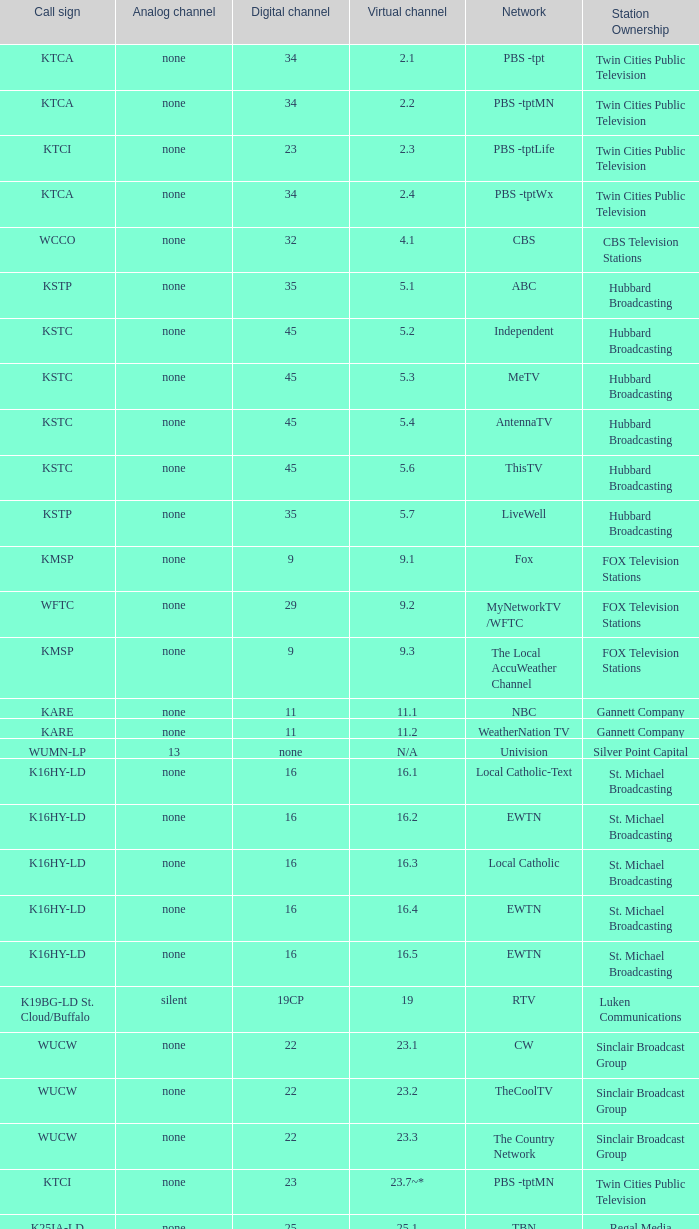Can you parse all the data within this table? {'header': ['Call sign', 'Analog channel', 'Digital channel', 'Virtual channel', 'Network', 'Station Ownership'], 'rows': [['KTCA', 'none', '34', '2.1', 'PBS -tpt', 'Twin Cities Public Television'], ['KTCA', 'none', '34', '2.2', 'PBS -tptMN', 'Twin Cities Public Television'], ['KTCI', 'none', '23', '2.3', 'PBS -tptLife', 'Twin Cities Public Television'], ['KTCA', 'none', '34', '2.4', 'PBS -tptWx', 'Twin Cities Public Television'], ['WCCO', 'none', '32', '4.1', 'CBS', 'CBS Television Stations'], ['KSTP', 'none', '35', '5.1', 'ABC', 'Hubbard Broadcasting'], ['KSTC', 'none', '45', '5.2', 'Independent', 'Hubbard Broadcasting'], ['KSTC', 'none', '45', '5.3', 'MeTV', 'Hubbard Broadcasting'], ['KSTC', 'none', '45', '5.4', 'AntennaTV', 'Hubbard Broadcasting'], ['KSTC', 'none', '45', '5.6', 'ThisTV', 'Hubbard Broadcasting'], ['KSTP', 'none', '35', '5.7', 'LiveWell', 'Hubbard Broadcasting'], ['KMSP', 'none', '9', '9.1', 'Fox', 'FOX Television Stations'], ['WFTC', 'none', '29', '9.2', 'MyNetworkTV /WFTC', 'FOX Television Stations'], ['KMSP', 'none', '9', '9.3', 'The Local AccuWeather Channel', 'FOX Television Stations'], ['KARE', 'none', '11', '11.1', 'NBC', 'Gannett Company'], ['KARE', 'none', '11', '11.2', 'WeatherNation TV', 'Gannett Company'], ['WUMN-LP', '13', 'none', 'N/A', 'Univision', 'Silver Point Capital'], ['K16HY-LD', 'none', '16', '16.1', 'Local Catholic-Text', 'St. Michael Broadcasting'], ['K16HY-LD', 'none', '16', '16.2', 'EWTN', 'St. Michael Broadcasting'], ['K16HY-LD', 'none', '16', '16.3', 'Local Catholic', 'St. Michael Broadcasting'], ['K16HY-LD', 'none', '16', '16.4', 'EWTN', 'St. Michael Broadcasting'], ['K16HY-LD', 'none', '16', '16.5', 'EWTN', 'St. Michael Broadcasting'], ['K19BG-LD St. Cloud/Buffalo', 'silent', '19CP', '19', 'RTV', 'Luken Communications'], ['WUCW', 'none', '22', '23.1', 'CW', 'Sinclair Broadcast Group'], ['WUCW', 'none', '22', '23.2', 'TheCoolTV', 'Sinclair Broadcast Group'], ['WUCW', 'none', '22', '23.3', 'The Country Network', 'Sinclair Broadcast Group'], ['KTCI', 'none', '23', '23.7~*', 'PBS -tptMN', 'Twin Cities Public Television'], ['K25IA-LD', 'none', '25', '25.1', 'TBN', 'Regal Media'], ['K25IA-LD', 'none', '25', '25.2', 'The Church Channel', 'Regal Media'], ['K25IA-LD', 'none', '25', '25.3', 'JCTV', 'Regal Media'], ['K25IA-LD', 'none', '25', '25.4', 'Smile Of A Child', 'Regal Media'], ['K25IA-LD', 'none', '25', '25.5', 'TBN Enlace', 'Regal Media'], ['W47CO-LD River Falls, Wisc.', 'none', '47', '28.1', 'PBS /WHWC', 'Wisconsin Public Television'], ['W47CO-LD River Falls, Wisc.', 'none', '47', '28.2', 'PBS -WISC/WHWC', 'Wisconsin Public Television'], ['W47CO-LD River Falls, Wisc.', 'none', '47', '28.3', 'PBS -Create/WHWC', 'Wisconsin Public Television'], ['WFTC', 'none', '29', '29.1', 'MyNetworkTV', 'FOX Television Stations'], ['KMSP', 'none', '9', '29.2', 'MyNetworkTV /WFTC', 'FOX Television Stations'], ['WFTC', 'none', '29', '29.3', 'Bounce TV', 'FOX Television Stations'], ['WFTC', 'none', '29', '29.4', 'Movies!', 'FOX Television Stations'], ['K33LN-LD', 'none', '33', '33.1', '3ABN', 'Three Angels Broadcasting Network'], ['K33LN-LD', 'none', '33', '33.2', '3ABN Proclaim!', 'Three Angels Broadcasting Network'], ['K33LN-LD', 'none', '33', '33.3', '3ABN Dare to Dream', 'Three Angels Broadcasting Network'], ['K33LN-LD', 'none', '33', '33.4', '3ABN Latino', 'Three Angels Broadcasting Network'], ['K33LN-LD', 'none', '33', '33.5', '3ABN Radio-Audio', 'Three Angels Broadcasting Network'], ['K33LN-LD', 'none', '33', '33.6', '3ABN Radio Latino-Audio', 'Three Angels Broadcasting Network'], ['K33LN-LD', 'none', '33', '33.7', 'Radio 74-Audio', 'Three Angels Broadcasting Network'], ['KPXM-TV', 'none', '40', '41.1', 'Ion Television', 'Ion Media Networks'], ['KPXM-TV', 'none', '40', '41.2', 'Qubo Kids', 'Ion Media Networks'], ['KPXM-TV', 'none', '40', '41.3', 'Ion Life', 'Ion Media Networks'], ['K43HB-LD', 'none', '43', '43.1', 'HSN', 'Ventana Television'], ['KHVM-LD', 'none', '48', '48.1', 'GCN - Religious', 'EICB TV'], ['KTCJ-LD', 'none', '50', '50.1', 'CTVN - Religious', 'EICB TV'], ['WDMI-LD', 'none', '31', '62.1', 'Daystar', 'Word of God Fellowship']]} What is the digital channel number for the nbc network? 11.0. 